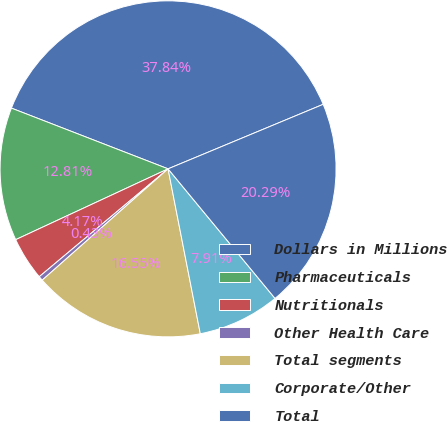<chart> <loc_0><loc_0><loc_500><loc_500><pie_chart><fcel>Dollars in Millions<fcel>Pharmaceuticals<fcel>Nutritionals<fcel>Other Health Care<fcel>Total segments<fcel>Corporate/Other<fcel>Total<nl><fcel>37.84%<fcel>12.81%<fcel>4.17%<fcel>0.43%<fcel>16.55%<fcel>7.91%<fcel>20.29%<nl></chart> 